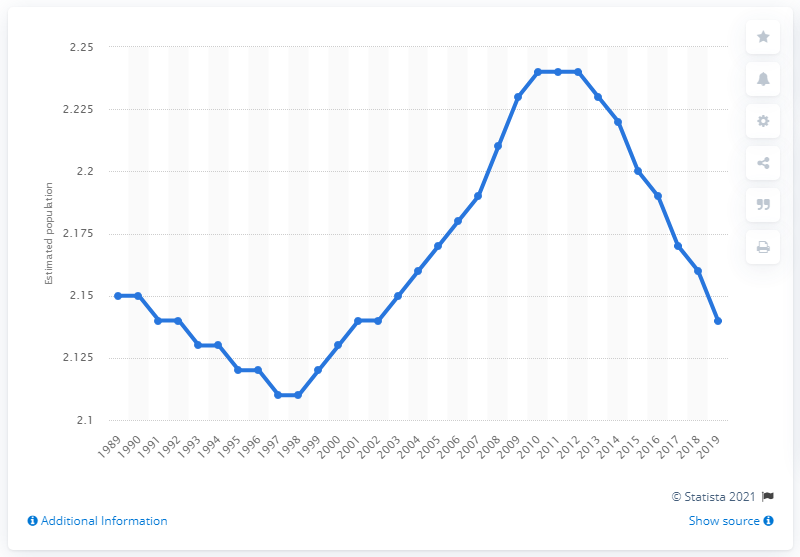Give some essential details in this illustration. According to data from 2019, the population of Paris was 2.14 million. In 2012, the population of Parisians was approximately 2.22 million. 